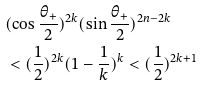<formula> <loc_0><loc_0><loc_500><loc_500>& ( \cos { \frac { \theta _ { + } } { 2 } } ) ^ { 2 k } ( \sin { \frac { \theta _ { + } } { 2 } } ) ^ { 2 n - 2 k } \\ & < ( \frac { 1 } { 2 } ) ^ { 2 k } ( 1 - \frac { 1 } { k } ) ^ { k } < ( \frac { 1 } { 2 } ) ^ { 2 k + 1 }</formula> 